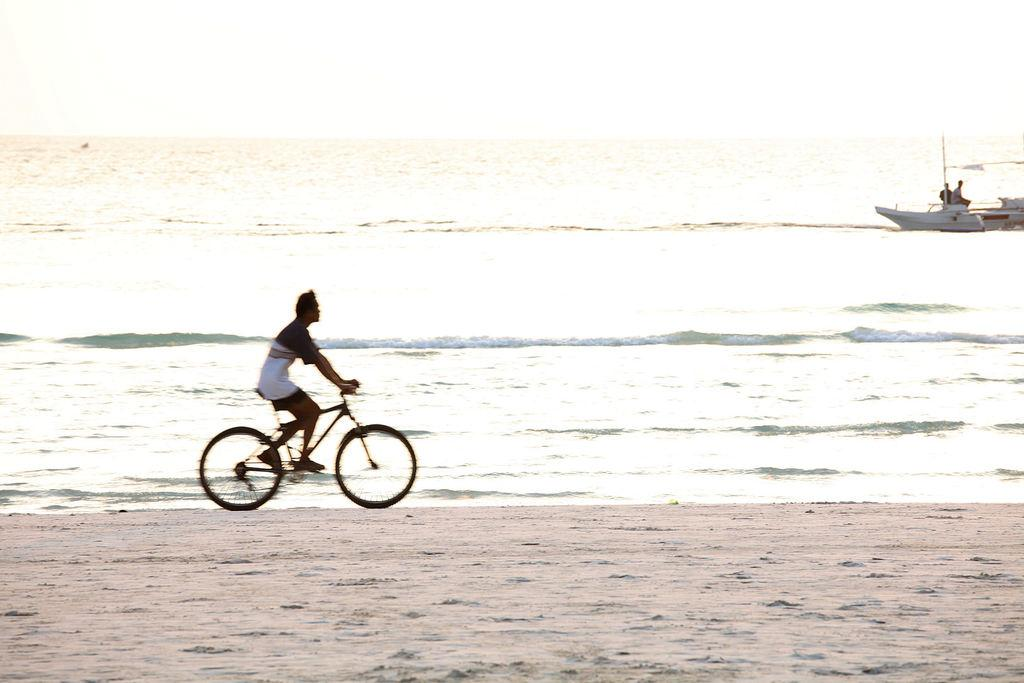What is the man in the image doing? The man is riding a bicycle in the image. What can be seen in the background of the image? There is water visible in the image, and a ship is in the water. What type of terrain is present in the image? There is sand in the image. What type of gate can be seen in the image? There is no gate present in the image. What type of bushes are growing near the sand in the image? There is no mention of bushes in the image; it only features a man riding a bicycle, water with a ship, and sand. 